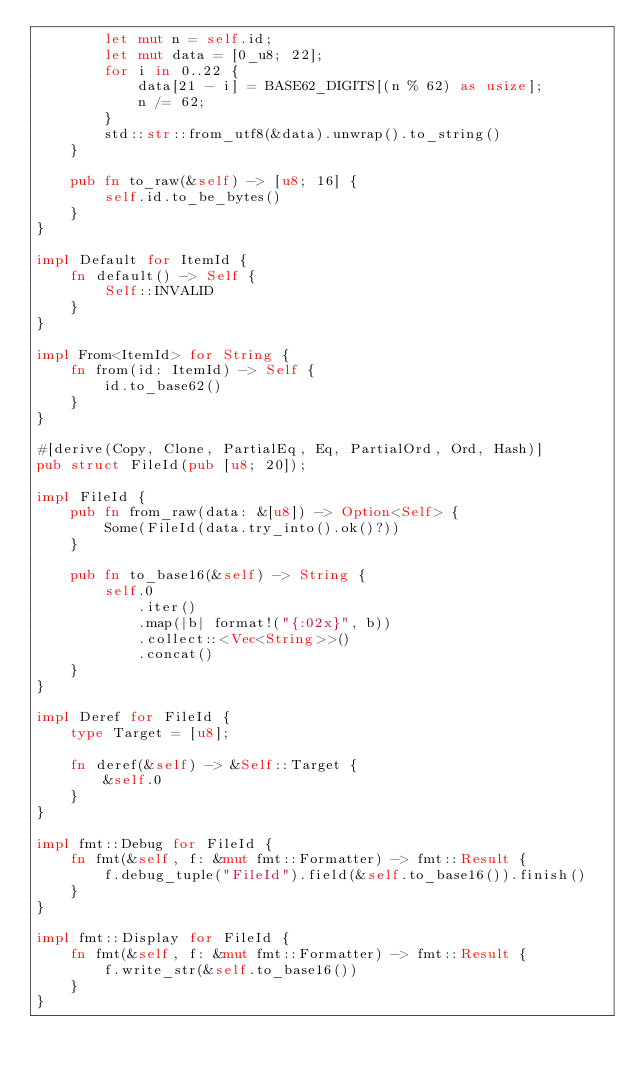<code> <loc_0><loc_0><loc_500><loc_500><_Rust_>        let mut n = self.id;
        let mut data = [0_u8; 22];
        for i in 0..22 {
            data[21 - i] = BASE62_DIGITS[(n % 62) as usize];
            n /= 62;
        }
        std::str::from_utf8(&data).unwrap().to_string()
    }

    pub fn to_raw(&self) -> [u8; 16] {
        self.id.to_be_bytes()
    }
}

impl Default for ItemId {
    fn default() -> Self {
        Self::INVALID
    }
}

impl From<ItemId> for String {
    fn from(id: ItemId) -> Self {
        id.to_base62()
    }
}

#[derive(Copy, Clone, PartialEq, Eq, PartialOrd, Ord, Hash)]
pub struct FileId(pub [u8; 20]);

impl FileId {
    pub fn from_raw(data: &[u8]) -> Option<Self> {
        Some(FileId(data.try_into().ok()?))
    }

    pub fn to_base16(&self) -> String {
        self.0
            .iter()
            .map(|b| format!("{:02x}", b))
            .collect::<Vec<String>>()
            .concat()
    }
}

impl Deref for FileId {
    type Target = [u8];

    fn deref(&self) -> &Self::Target {
        &self.0
    }
}

impl fmt::Debug for FileId {
    fn fmt(&self, f: &mut fmt::Formatter) -> fmt::Result {
        f.debug_tuple("FileId").field(&self.to_base16()).finish()
    }
}

impl fmt::Display for FileId {
    fn fmt(&self, f: &mut fmt::Formatter) -> fmt::Result {
        f.write_str(&self.to_base16())
    }
}
</code> 